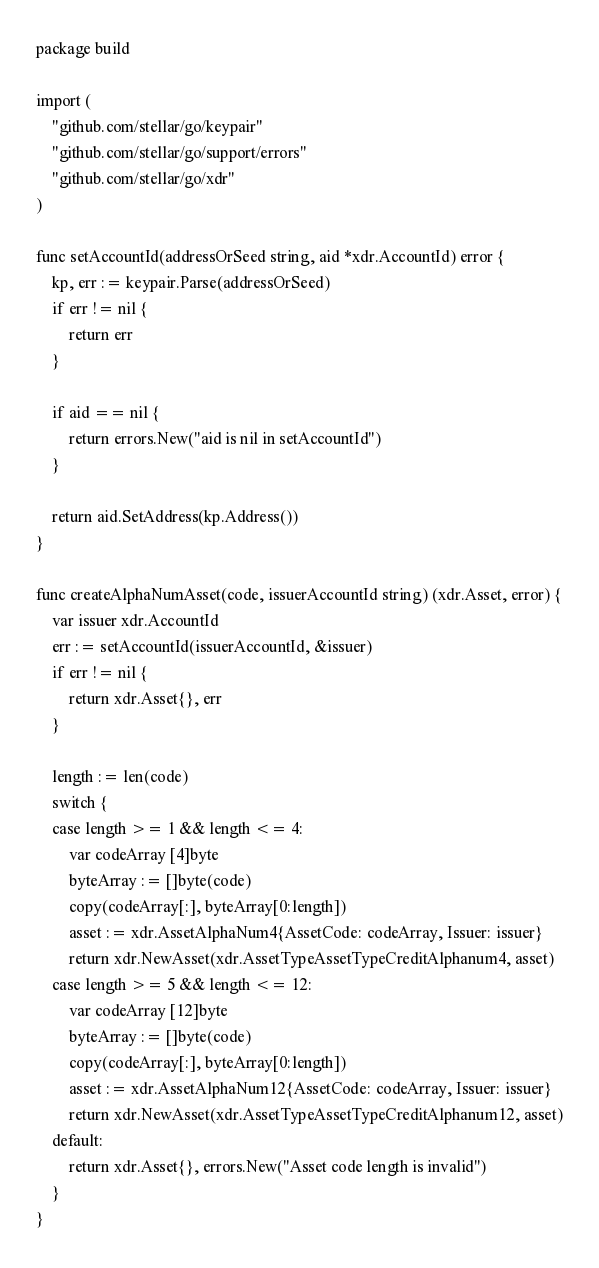<code> <loc_0><loc_0><loc_500><loc_500><_Go_>package build

import (
	"github.com/stellar/go/keypair"
	"github.com/stellar/go/support/errors"
	"github.com/stellar/go/xdr"
)

func setAccountId(addressOrSeed string, aid *xdr.AccountId) error {
	kp, err := keypair.Parse(addressOrSeed)
	if err != nil {
		return err
	}

	if aid == nil {
		return errors.New("aid is nil in setAccountId")
	}

	return aid.SetAddress(kp.Address())
}

func createAlphaNumAsset(code, issuerAccountId string) (xdr.Asset, error) {
	var issuer xdr.AccountId
	err := setAccountId(issuerAccountId, &issuer)
	if err != nil {
		return xdr.Asset{}, err
	}

	length := len(code)
	switch {
	case length >= 1 && length <= 4:
		var codeArray [4]byte
		byteArray := []byte(code)
		copy(codeArray[:], byteArray[0:length])
		asset := xdr.AssetAlphaNum4{AssetCode: codeArray, Issuer: issuer}
		return xdr.NewAsset(xdr.AssetTypeAssetTypeCreditAlphanum4, asset)
	case length >= 5 && length <= 12:
		var codeArray [12]byte
		byteArray := []byte(code)
		copy(codeArray[:], byteArray[0:length])
		asset := xdr.AssetAlphaNum12{AssetCode: codeArray, Issuer: issuer}
		return xdr.NewAsset(xdr.AssetTypeAssetTypeCreditAlphanum12, asset)
	default:
		return xdr.Asset{}, errors.New("Asset code length is invalid")
	}
}
</code> 